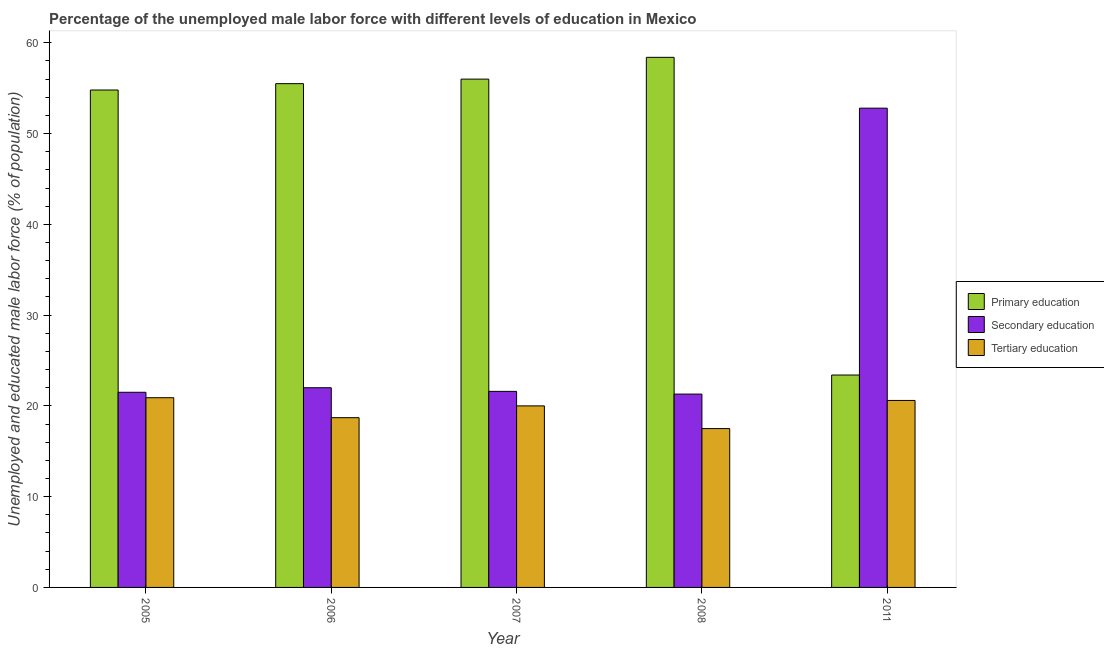Are the number of bars per tick equal to the number of legend labels?
Your answer should be very brief. Yes. How many bars are there on the 3rd tick from the right?
Offer a terse response. 3. In how many cases, is the number of bars for a given year not equal to the number of legend labels?
Your answer should be very brief. 0. What is the percentage of male labor force who received secondary education in 2008?
Make the answer very short. 21.3. Across all years, what is the maximum percentage of male labor force who received tertiary education?
Give a very brief answer. 20.9. Across all years, what is the minimum percentage of male labor force who received primary education?
Keep it short and to the point. 23.4. What is the total percentage of male labor force who received tertiary education in the graph?
Your answer should be compact. 97.7. What is the difference between the percentage of male labor force who received primary education in 2007 and that in 2008?
Your answer should be very brief. -2.4. What is the difference between the percentage of male labor force who received tertiary education in 2007 and the percentage of male labor force who received secondary education in 2006?
Your response must be concise. 1.3. What is the average percentage of male labor force who received primary education per year?
Offer a very short reply. 49.62. In the year 2008, what is the difference between the percentage of male labor force who received tertiary education and percentage of male labor force who received primary education?
Provide a short and direct response. 0. In how many years, is the percentage of male labor force who received tertiary education greater than 40 %?
Provide a short and direct response. 0. What is the ratio of the percentage of male labor force who received secondary education in 2005 to that in 2011?
Keep it short and to the point. 0.41. Is the percentage of male labor force who received secondary education in 2007 less than that in 2011?
Your response must be concise. Yes. What is the difference between the highest and the second highest percentage of male labor force who received primary education?
Ensure brevity in your answer.  2.4. What is the difference between the highest and the lowest percentage of male labor force who received tertiary education?
Keep it short and to the point. 3.4. What does the 1st bar from the left in 2011 represents?
Provide a short and direct response. Primary education. What does the 1st bar from the right in 2006 represents?
Give a very brief answer. Tertiary education. Is it the case that in every year, the sum of the percentage of male labor force who received primary education and percentage of male labor force who received secondary education is greater than the percentage of male labor force who received tertiary education?
Keep it short and to the point. Yes. How many bars are there?
Offer a very short reply. 15. How many years are there in the graph?
Offer a terse response. 5. Are the values on the major ticks of Y-axis written in scientific E-notation?
Ensure brevity in your answer.  No. Does the graph contain any zero values?
Ensure brevity in your answer.  No. Does the graph contain grids?
Provide a short and direct response. No. Where does the legend appear in the graph?
Provide a short and direct response. Center right. How many legend labels are there?
Your answer should be compact. 3. What is the title of the graph?
Your answer should be very brief. Percentage of the unemployed male labor force with different levels of education in Mexico. What is the label or title of the X-axis?
Ensure brevity in your answer.  Year. What is the label or title of the Y-axis?
Your response must be concise. Unemployed and educated male labor force (% of population). What is the Unemployed and educated male labor force (% of population) of Primary education in 2005?
Give a very brief answer. 54.8. What is the Unemployed and educated male labor force (% of population) of Tertiary education in 2005?
Make the answer very short. 20.9. What is the Unemployed and educated male labor force (% of population) in Primary education in 2006?
Your answer should be compact. 55.5. What is the Unemployed and educated male labor force (% of population) in Tertiary education in 2006?
Provide a succinct answer. 18.7. What is the Unemployed and educated male labor force (% of population) of Secondary education in 2007?
Ensure brevity in your answer.  21.6. What is the Unemployed and educated male labor force (% of population) of Tertiary education in 2007?
Offer a terse response. 20. What is the Unemployed and educated male labor force (% of population) in Primary education in 2008?
Provide a succinct answer. 58.4. What is the Unemployed and educated male labor force (% of population) of Secondary education in 2008?
Keep it short and to the point. 21.3. What is the Unemployed and educated male labor force (% of population) in Tertiary education in 2008?
Make the answer very short. 17.5. What is the Unemployed and educated male labor force (% of population) of Primary education in 2011?
Keep it short and to the point. 23.4. What is the Unemployed and educated male labor force (% of population) of Secondary education in 2011?
Offer a terse response. 52.8. What is the Unemployed and educated male labor force (% of population) in Tertiary education in 2011?
Your answer should be compact. 20.6. Across all years, what is the maximum Unemployed and educated male labor force (% of population) of Primary education?
Keep it short and to the point. 58.4. Across all years, what is the maximum Unemployed and educated male labor force (% of population) in Secondary education?
Make the answer very short. 52.8. Across all years, what is the maximum Unemployed and educated male labor force (% of population) in Tertiary education?
Ensure brevity in your answer.  20.9. Across all years, what is the minimum Unemployed and educated male labor force (% of population) in Primary education?
Offer a very short reply. 23.4. Across all years, what is the minimum Unemployed and educated male labor force (% of population) of Secondary education?
Provide a short and direct response. 21.3. What is the total Unemployed and educated male labor force (% of population) in Primary education in the graph?
Your answer should be very brief. 248.1. What is the total Unemployed and educated male labor force (% of population) of Secondary education in the graph?
Offer a terse response. 139.2. What is the total Unemployed and educated male labor force (% of population) in Tertiary education in the graph?
Offer a terse response. 97.7. What is the difference between the Unemployed and educated male labor force (% of population) in Secondary education in 2005 and that in 2006?
Make the answer very short. -0.5. What is the difference between the Unemployed and educated male labor force (% of population) of Secondary education in 2005 and that in 2007?
Offer a terse response. -0.1. What is the difference between the Unemployed and educated male labor force (% of population) in Tertiary education in 2005 and that in 2007?
Offer a terse response. 0.9. What is the difference between the Unemployed and educated male labor force (% of population) of Primary education in 2005 and that in 2008?
Keep it short and to the point. -3.6. What is the difference between the Unemployed and educated male labor force (% of population) in Secondary education in 2005 and that in 2008?
Ensure brevity in your answer.  0.2. What is the difference between the Unemployed and educated male labor force (% of population) of Tertiary education in 2005 and that in 2008?
Your answer should be very brief. 3.4. What is the difference between the Unemployed and educated male labor force (% of population) in Primary education in 2005 and that in 2011?
Your answer should be very brief. 31.4. What is the difference between the Unemployed and educated male labor force (% of population) of Secondary education in 2005 and that in 2011?
Offer a terse response. -31.3. What is the difference between the Unemployed and educated male labor force (% of population) in Tertiary education in 2005 and that in 2011?
Keep it short and to the point. 0.3. What is the difference between the Unemployed and educated male labor force (% of population) in Primary education in 2006 and that in 2007?
Provide a succinct answer. -0.5. What is the difference between the Unemployed and educated male labor force (% of population) in Tertiary education in 2006 and that in 2007?
Keep it short and to the point. -1.3. What is the difference between the Unemployed and educated male labor force (% of population) in Primary education in 2006 and that in 2011?
Offer a very short reply. 32.1. What is the difference between the Unemployed and educated male labor force (% of population) of Secondary education in 2006 and that in 2011?
Offer a terse response. -30.8. What is the difference between the Unemployed and educated male labor force (% of population) in Tertiary education in 2006 and that in 2011?
Your answer should be compact. -1.9. What is the difference between the Unemployed and educated male labor force (% of population) in Tertiary education in 2007 and that in 2008?
Offer a terse response. 2.5. What is the difference between the Unemployed and educated male labor force (% of population) in Primary education in 2007 and that in 2011?
Make the answer very short. 32.6. What is the difference between the Unemployed and educated male labor force (% of population) of Secondary education in 2007 and that in 2011?
Your response must be concise. -31.2. What is the difference between the Unemployed and educated male labor force (% of population) of Secondary education in 2008 and that in 2011?
Offer a terse response. -31.5. What is the difference between the Unemployed and educated male labor force (% of population) in Primary education in 2005 and the Unemployed and educated male labor force (% of population) in Secondary education in 2006?
Provide a short and direct response. 32.8. What is the difference between the Unemployed and educated male labor force (% of population) in Primary education in 2005 and the Unemployed and educated male labor force (% of population) in Tertiary education in 2006?
Your response must be concise. 36.1. What is the difference between the Unemployed and educated male labor force (% of population) of Secondary education in 2005 and the Unemployed and educated male labor force (% of population) of Tertiary education in 2006?
Your response must be concise. 2.8. What is the difference between the Unemployed and educated male labor force (% of population) in Primary education in 2005 and the Unemployed and educated male labor force (% of population) in Secondary education in 2007?
Ensure brevity in your answer.  33.2. What is the difference between the Unemployed and educated male labor force (% of population) in Primary education in 2005 and the Unemployed and educated male labor force (% of population) in Tertiary education in 2007?
Ensure brevity in your answer.  34.8. What is the difference between the Unemployed and educated male labor force (% of population) in Primary education in 2005 and the Unemployed and educated male labor force (% of population) in Secondary education in 2008?
Offer a terse response. 33.5. What is the difference between the Unemployed and educated male labor force (% of population) in Primary education in 2005 and the Unemployed and educated male labor force (% of population) in Tertiary education in 2008?
Keep it short and to the point. 37.3. What is the difference between the Unemployed and educated male labor force (% of population) in Primary education in 2005 and the Unemployed and educated male labor force (% of population) in Tertiary education in 2011?
Your answer should be compact. 34.2. What is the difference between the Unemployed and educated male labor force (% of population) in Primary education in 2006 and the Unemployed and educated male labor force (% of population) in Secondary education in 2007?
Make the answer very short. 33.9. What is the difference between the Unemployed and educated male labor force (% of population) of Primary education in 2006 and the Unemployed and educated male labor force (% of population) of Tertiary education in 2007?
Offer a terse response. 35.5. What is the difference between the Unemployed and educated male labor force (% of population) in Secondary education in 2006 and the Unemployed and educated male labor force (% of population) in Tertiary education in 2007?
Keep it short and to the point. 2. What is the difference between the Unemployed and educated male labor force (% of population) in Primary education in 2006 and the Unemployed and educated male labor force (% of population) in Secondary education in 2008?
Provide a succinct answer. 34.2. What is the difference between the Unemployed and educated male labor force (% of population) of Secondary education in 2006 and the Unemployed and educated male labor force (% of population) of Tertiary education in 2008?
Offer a very short reply. 4.5. What is the difference between the Unemployed and educated male labor force (% of population) in Primary education in 2006 and the Unemployed and educated male labor force (% of population) in Secondary education in 2011?
Your response must be concise. 2.7. What is the difference between the Unemployed and educated male labor force (% of population) in Primary education in 2006 and the Unemployed and educated male labor force (% of population) in Tertiary education in 2011?
Ensure brevity in your answer.  34.9. What is the difference between the Unemployed and educated male labor force (% of population) in Secondary education in 2006 and the Unemployed and educated male labor force (% of population) in Tertiary education in 2011?
Your answer should be compact. 1.4. What is the difference between the Unemployed and educated male labor force (% of population) of Primary education in 2007 and the Unemployed and educated male labor force (% of population) of Secondary education in 2008?
Make the answer very short. 34.7. What is the difference between the Unemployed and educated male labor force (% of population) in Primary education in 2007 and the Unemployed and educated male labor force (% of population) in Tertiary education in 2008?
Offer a very short reply. 38.5. What is the difference between the Unemployed and educated male labor force (% of population) of Secondary education in 2007 and the Unemployed and educated male labor force (% of population) of Tertiary education in 2008?
Make the answer very short. 4.1. What is the difference between the Unemployed and educated male labor force (% of population) in Primary education in 2007 and the Unemployed and educated male labor force (% of population) in Tertiary education in 2011?
Your response must be concise. 35.4. What is the difference between the Unemployed and educated male labor force (% of population) of Primary education in 2008 and the Unemployed and educated male labor force (% of population) of Secondary education in 2011?
Give a very brief answer. 5.6. What is the difference between the Unemployed and educated male labor force (% of population) of Primary education in 2008 and the Unemployed and educated male labor force (% of population) of Tertiary education in 2011?
Your answer should be very brief. 37.8. What is the difference between the Unemployed and educated male labor force (% of population) in Secondary education in 2008 and the Unemployed and educated male labor force (% of population) in Tertiary education in 2011?
Provide a succinct answer. 0.7. What is the average Unemployed and educated male labor force (% of population) in Primary education per year?
Offer a terse response. 49.62. What is the average Unemployed and educated male labor force (% of population) of Secondary education per year?
Ensure brevity in your answer.  27.84. What is the average Unemployed and educated male labor force (% of population) in Tertiary education per year?
Give a very brief answer. 19.54. In the year 2005, what is the difference between the Unemployed and educated male labor force (% of population) of Primary education and Unemployed and educated male labor force (% of population) of Secondary education?
Offer a very short reply. 33.3. In the year 2005, what is the difference between the Unemployed and educated male labor force (% of population) of Primary education and Unemployed and educated male labor force (% of population) of Tertiary education?
Your answer should be very brief. 33.9. In the year 2006, what is the difference between the Unemployed and educated male labor force (% of population) of Primary education and Unemployed and educated male labor force (% of population) of Secondary education?
Offer a very short reply. 33.5. In the year 2006, what is the difference between the Unemployed and educated male labor force (% of population) in Primary education and Unemployed and educated male labor force (% of population) in Tertiary education?
Your answer should be compact. 36.8. In the year 2007, what is the difference between the Unemployed and educated male labor force (% of population) of Primary education and Unemployed and educated male labor force (% of population) of Secondary education?
Offer a terse response. 34.4. In the year 2007, what is the difference between the Unemployed and educated male labor force (% of population) of Primary education and Unemployed and educated male labor force (% of population) of Tertiary education?
Make the answer very short. 36. In the year 2008, what is the difference between the Unemployed and educated male labor force (% of population) in Primary education and Unemployed and educated male labor force (% of population) in Secondary education?
Your response must be concise. 37.1. In the year 2008, what is the difference between the Unemployed and educated male labor force (% of population) of Primary education and Unemployed and educated male labor force (% of population) of Tertiary education?
Your response must be concise. 40.9. In the year 2008, what is the difference between the Unemployed and educated male labor force (% of population) in Secondary education and Unemployed and educated male labor force (% of population) in Tertiary education?
Your response must be concise. 3.8. In the year 2011, what is the difference between the Unemployed and educated male labor force (% of population) in Primary education and Unemployed and educated male labor force (% of population) in Secondary education?
Your response must be concise. -29.4. In the year 2011, what is the difference between the Unemployed and educated male labor force (% of population) in Primary education and Unemployed and educated male labor force (% of population) in Tertiary education?
Your answer should be very brief. 2.8. In the year 2011, what is the difference between the Unemployed and educated male labor force (% of population) in Secondary education and Unemployed and educated male labor force (% of population) in Tertiary education?
Offer a terse response. 32.2. What is the ratio of the Unemployed and educated male labor force (% of population) of Primary education in 2005 to that in 2006?
Your response must be concise. 0.99. What is the ratio of the Unemployed and educated male labor force (% of population) of Secondary education in 2005 to that in 2006?
Give a very brief answer. 0.98. What is the ratio of the Unemployed and educated male labor force (% of population) of Tertiary education in 2005 to that in 2006?
Provide a short and direct response. 1.12. What is the ratio of the Unemployed and educated male labor force (% of population) in Primary education in 2005 to that in 2007?
Offer a very short reply. 0.98. What is the ratio of the Unemployed and educated male labor force (% of population) in Tertiary education in 2005 to that in 2007?
Your response must be concise. 1.04. What is the ratio of the Unemployed and educated male labor force (% of population) of Primary education in 2005 to that in 2008?
Provide a short and direct response. 0.94. What is the ratio of the Unemployed and educated male labor force (% of population) in Secondary education in 2005 to that in 2008?
Keep it short and to the point. 1.01. What is the ratio of the Unemployed and educated male labor force (% of population) of Tertiary education in 2005 to that in 2008?
Your response must be concise. 1.19. What is the ratio of the Unemployed and educated male labor force (% of population) in Primary education in 2005 to that in 2011?
Your answer should be compact. 2.34. What is the ratio of the Unemployed and educated male labor force (% of population) in Secondary education in 2005 to that in 2011?
Provide a succinct answer. 0.41. What is the ratio of the Unemployed and educated male labor force (% of population) of Tertiary education in 2005 to that in 2011?
Your answer should be very brief. 1.01. What is the ratio of the Unemployed and educated male labor force (% of population) in Secondary education in 2006 to that in 2007?
Provide a short and direct response. 1.02. What is the ratio of the Unemployed and educated male labor force (% of population) in Tertiary education in 2006 to that in 2007?
Your answer should be compact. 0.94. What is the ratio of the Unemployed and educated male labor force (% of population) in Primary education in 2006 to that in 2008?
Ensure brevity in your answer.  0.95. What is the ratio of the Unemployed and educated male labor force (% of population) in Secondary education in 2006 to that in 2008?
Offer a terse response. 1.03. What is the ratio of the Unemployed and educated male labor force (% of population) in Tertiary education in 2006 to that in 2008?
Your answer should be compact. 1.07. What is the ratio of the Unemployed and educated male labor force (% of population) in Primary education in 2006 to that in 2011?
Your answer should be very brief. 2.37. What is the ratio of the Unemployed and educated male labor force (% of population) in Secondary education in 2006 to that in 2011?
Make the answer very short. 0.42. What is the ratio of the Unemployed and educated male labor force (% of population) of Tertiary education in 2006 to that in 2011?
Offer a very short reply. 0.91. What is the ratio of the Unemployed and educated male labor force (% of population) in Primary education in 2007 to that in 2008?
Ensure brevity in your answer.  0.96. What is the ratio of the Unemployed and educated male labor force (% of population) in Secondary education in 2007 to that in 2008?
Your response must be concise. 1.01. What is the ratio of the Unemployed and educated male labor force (% of population) in Tertiary education in 2007 to that in 2008?
Keep it short and to the point. 1.14. What is the ratio of the Unemployed and educated male labor force (% of population) in Primary education in 2007 to that in 2011?
Ensure brevity in your answer.  2.39. What is the ratio of the Unemployed and educated male labor force (% of population) in Secondary education in 2007 to that in 2011?
Provide a short and direct response. 0.41. What is the ratio of the Unemployed and educated male labor force (% of population) of Tertiary education in 2007 to that in 2011?
Offer a very short reply. 0.97. What is the ratio of the Unemployed and educated male labor force (% of population) in Primary education in 2008 to that in 2011?
Keep it short and to the point. 2.5. What is the ratio of the Unemployed and educated male labor force (% of population) in Secondary education in 2008 to that in 2011?
Ensure brevity in your answer.  0.4. What is the ratio of the Unemployed and educated male labor force (% of population) of Tertiary education in 2008 to that in 2011?
Your response must be concise. 0.85. What is the difference between the highest and the second highest Unemployed and educated male labor force (% of population) of Primary education?
Provide a short and direct response. 2.4. What is the difference between the highest and the second highest Unemployed and educated male labor force (% of population) in Secondary education?
Keep it short and to the point. 30.8. What is the difference between the highest and the second highest Unemployed and educated male labor force (% of population) in Tertiary education?
Your answer should be compact. 0.3. What is the difference between the highest and the lowest Unemployed and educated male labor force (% of population) in Primary education?
Make the answer very short. 35. What is the difference between the highest and the lowest Unemployed and educated male labor force (% of population) in Secondary education?
Your answer should be compact. 31.5. 